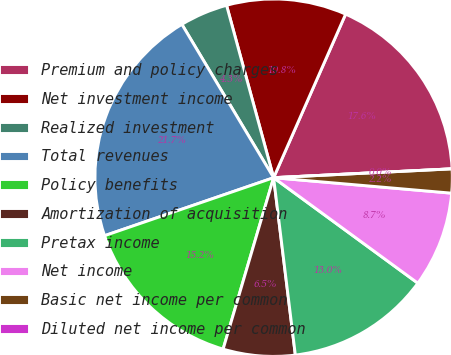Convert chart. <chart><loc_0><loc_0><loc_500><loc_500><pie_chart><fcel>Premium and policy charges<fcel>Net investment income<fcel>Realized investment<fcel>Total revenues<fcel>Policy benefits<fcel>Amortization of acquisition<fcel>Pretax income<fcel>Net income<fcel>Basic net income per common<fcel>Diluted net income per common<nl><fcel>17.61%<fcel>10.84%<fcel>4.34%<fcel>21.68%<fcel>15.18%<fcel>6.5%<fcel>13.01%<fcel>8.67%<fcel>2.17%<fcel>0.0%<nl></chart> 